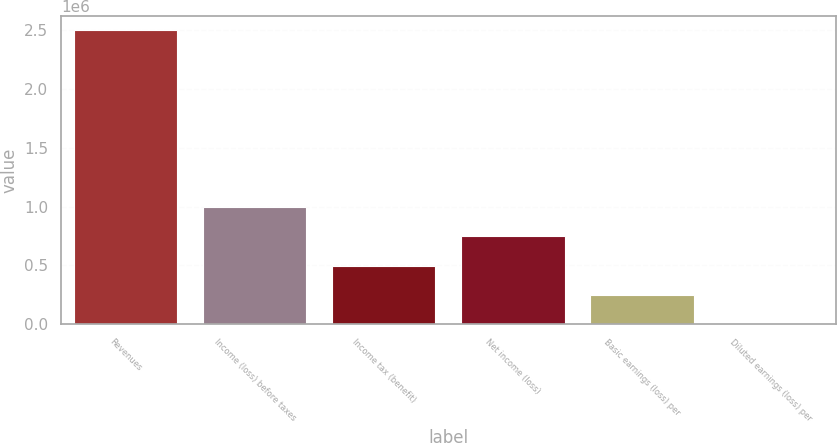<chart> <loc_0><loc_0><loc_500><loc_500><bar_chart><fcel>Revenues<fcel>Income (loss) before taxes<fcel>Income tax (benefit)<fcel>Net income (loss)<fcel>Basic earnings (loss) per<fcel>Diluted earnings (loss) per<nl><fcel>2.49602e+06<fcel>998408<fcel>499205<fcel>748807<fcel>249603<fcel>1.77<nl></chart> 